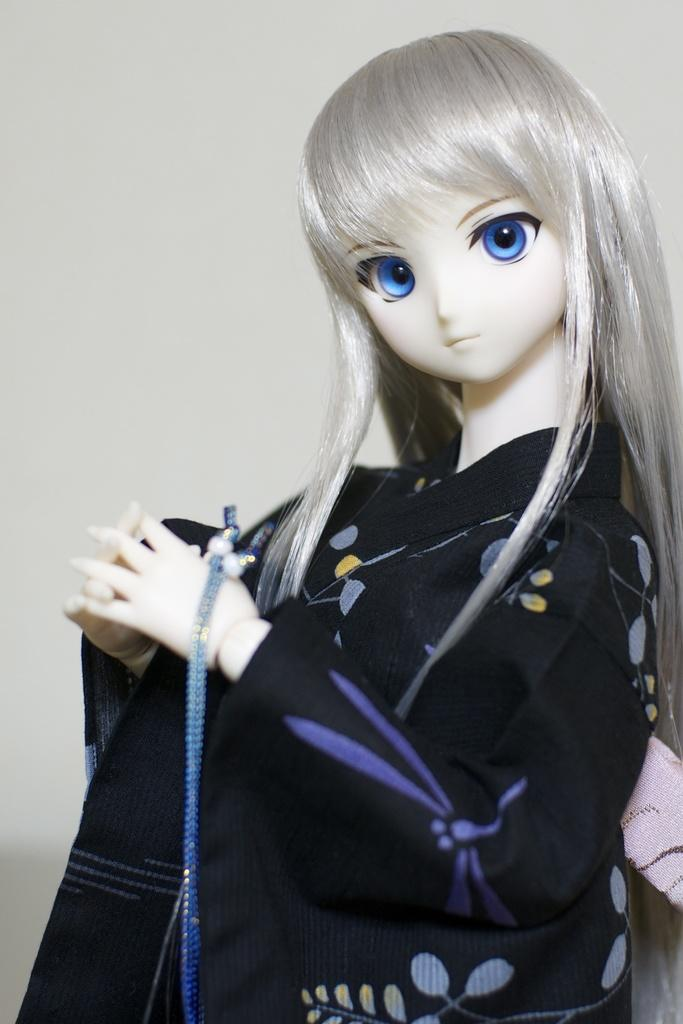What is the main subject in the center of the image? There is a Barbie doll in the center of the image. What can be seen in the background of the image? There is a wall in the background of the image. What type of art can be seen on the branch in the image? There is no branch or art present in the image; it only features a Barbie doll and a wall in the background. 